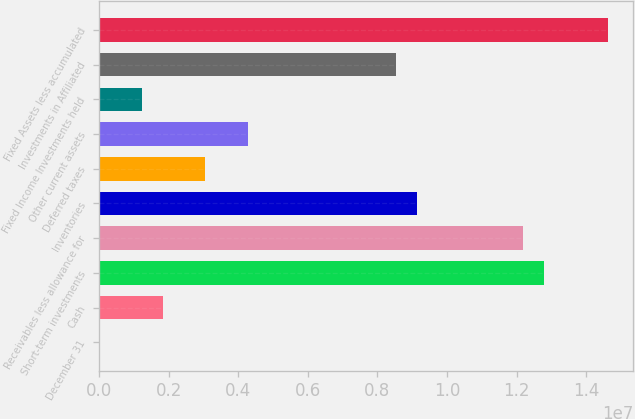<chart> <loc_0><loc_0><loc_500><loc_500><bar_chart><fcel>December 31<fcel>Cash<fcel>Short-term investments<fcel>Receivables less allowance for<fcel>Inventories<fcel>Deferred taxes<fcel>Other current assets<fcel>Fixed Income Investments held<fcel>Investments in Affiliated<fcel>Fixed Assets less accumulated<nl><fcel>2003<fcel>1.83063e+06<fcel>1.28024e+07<fcel>1.21928e+07<fcel>9.14513e+06<fcel>3.04971e+06<fcel>4.26879e+06<fcel>1.22109e+06<fcel>8.53558e+06<fcel>1.4631e+07<nl></chart> 